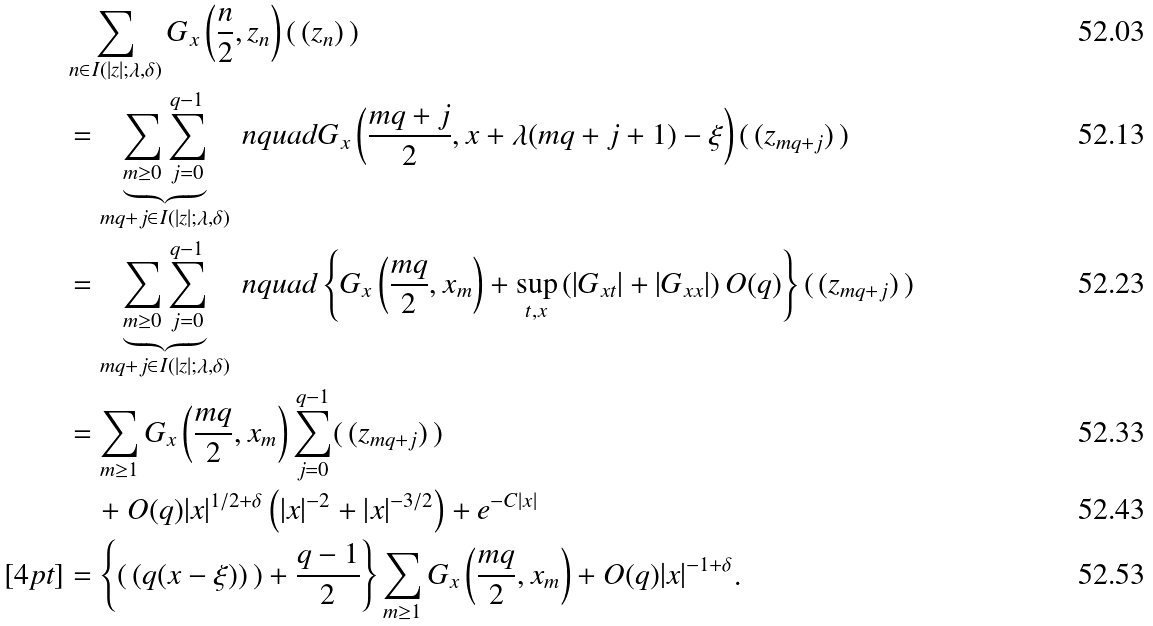Convert formula to latex. <formula><loc_0><loc_0><loc_500><loc_500>& \sum _ { n \in I ( | z | ; \lambda , \delta ) } G _ { x } \left ( \frac { n } { 2 } , z _ { n } \right ) ( \, ( z _ { n } ) \, ) \\ & = \underbrace { \sum _ { m \geq 0 } \sum _ { j = 0 } ^ { q - 1 } } _ { m q + j \in I ( | z | ; \lambda , \delta ) } \ n q u a d G _ { x } \left ( \frac { m q + j } { 2 } , x + \lambda ( m q + j + 1 ) - \xi \right ) ( \, ( z _ { m q + j } ) \, ) \\ & = \underbrace { \sum _ { m \geq 0 } \sum _ { j = 0 } ^ { q - 1 } } _ { m q + j \in I ( | z | ; \lambda , \delta ) } \ n q u a d \left \{ G _ { x } \left ( \frac { m q } { 2 } , x _ { m } \right ) + \sup _ { t , x } \left ( | G _ { x t } | + | G _ { x x } | \right ) O ( q ) \right \} ( \, ( z _ { m q + j } ) \, ) \\ & = \sum _ { m \geq 1 } G _ { x } \left ( \frac { m q } { 2 } , x _ { m } \right ) \sum _ { j = 0 } ^ { q - 1 } ( \, ( z _ { m q + j } ) \, ) \\ & \quad + O ( q ) | x | ^ { 1 / 2 + \delta } \left ( | x | ^ { - 2 } + | x | ^ { - 3 / 2 } \right ) + e ^ { - C | x | } \\ [ 4 p t ] & = \left \{ ( \, ( q ( x - \xi ) ) \, ) + \frac { q - 1 } { 2 } \right \} \sum _ { m \geq 1 } G _ { x } \left ( \frac { m q } { 2 } , x _ { m } \right ) + O ( q ) | x | ^ { - 1 + \delta } .</formula> 